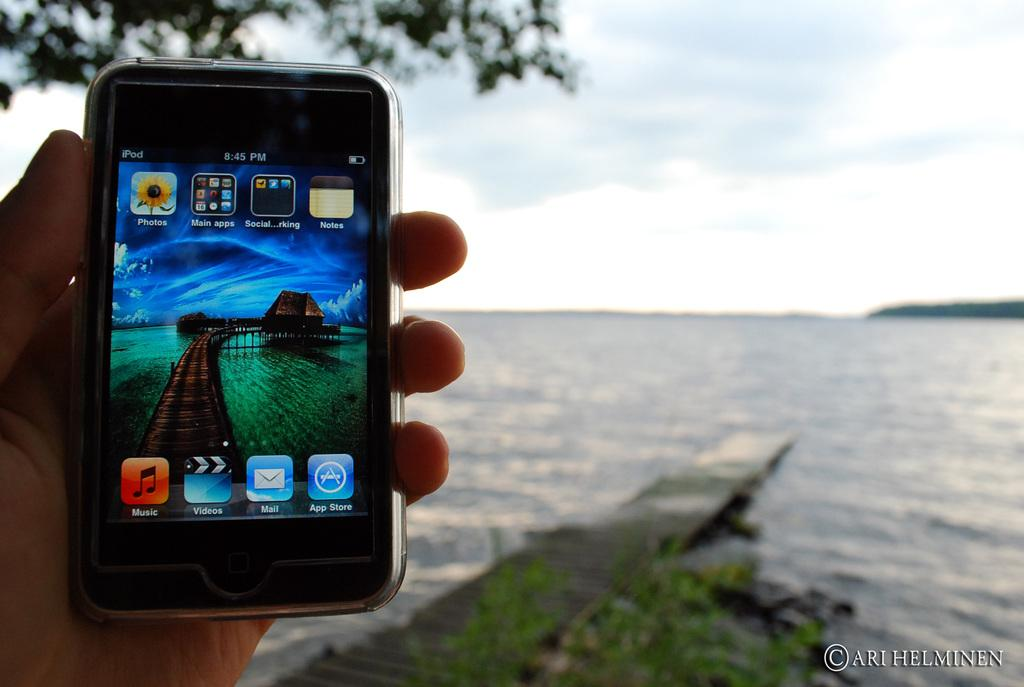<image>
Render a clear and concise summary of the photo. A person is holding a cell phone that says iPod in the top left corner and an ocean is in the background. 